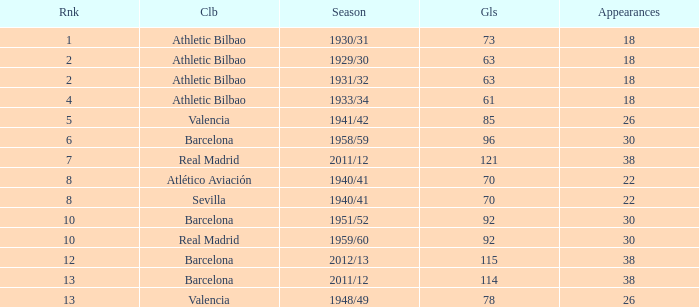Would you mind parsing the complete table? {'header': ['Rnk', 'Clb', 'Season', 'Gls', 'Appearances'], 'rows': [['1', 'Athletic Bilbao', '1930/31', '73', '18'], ['2', 'Athletic Bilbao', '1929/30', '63', '18'], ['2', 'Athletic Bilbao', '1931/32', '63', '18'], ['4', 'Athletic Bilbao', '1933/34', '61', '18'], ['5', 'Valencia', '1941/42', '85', '26'], ['6', 'Barcelona', '1958/59', '96', '30'], ['7', 'Real Madrid', '2011/12', '121', '38'], ['8', 'Atlético Aviación', '1940/41', '70', '22'], ['8', 'Sevilla', '1940/41', '70', '22'], ['10', 'Barcelona', '1951/52', '92', '30'], ['10', 'Real Madrid', '1959/60', '92', '30'], ['12', 'Barcelona', '2012/13', '115', '38'], ['13', 'Barcelona', '2011/12', '114', '38'], ['13', 'Valencia', '1948/49', '78', '26']]} Who was the club having less than 22 apps and ranked less than 2? Athletic Bilbao. 